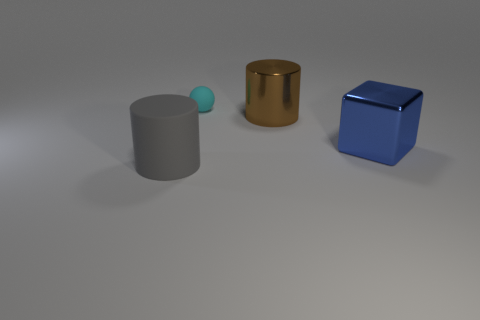Add 3 brown shiny things. How many objects exist? 7 Subtract all spheres. How many objects are left? 3 Subtract 1 brown cylinders. How many objects are left? 3 Subtract all tiny cyan shiny cylinders. Subtract all big metal things. How many objects are left? 2 Add 1 shiny blocks. How many shiny blocks are left? 2 Add 4 big brown matte cylinders. How many big brown matte cylinders exist? 4 